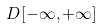Convert formula to latex. <formula><loc_0><loc_0><loc_500><loc_500>D [ - \infty , + \infty ]</formula> 